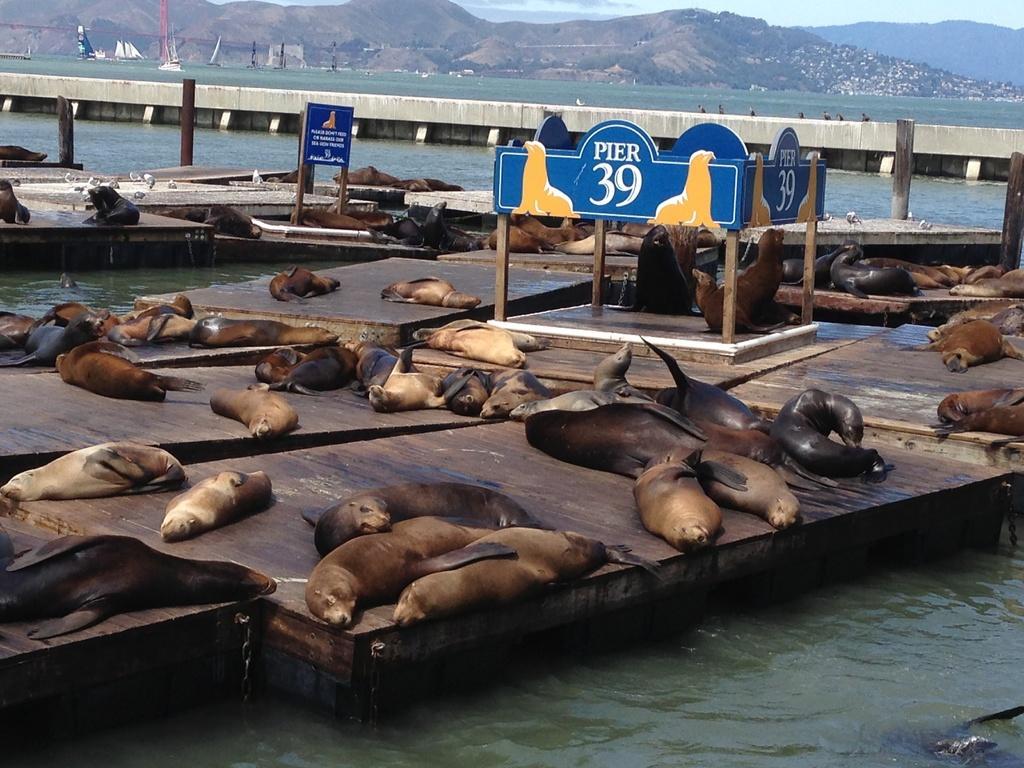Describe this image in one or two sentences. In this picture we can see some sea lions here, at the bottom there is water, we can see a board here, in the background there is a hill, we can see the sky at the top of the picture. 